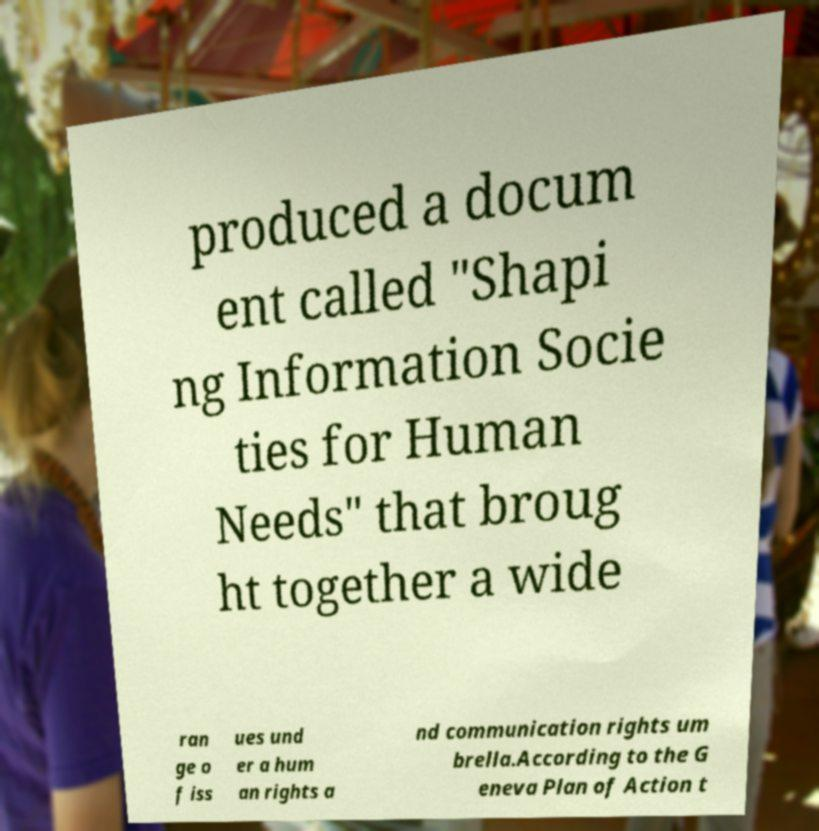There's text embedded in this image that I need extracted. Can you transcribe it verbatim? produced a docum ent called "Shapi ng Information Socie ties for Human Needs" that broug ht together a wide ran ge o f iss ues und er a hum an rights a nd communication rights um brella.According to the G eneva Plan of Action t 